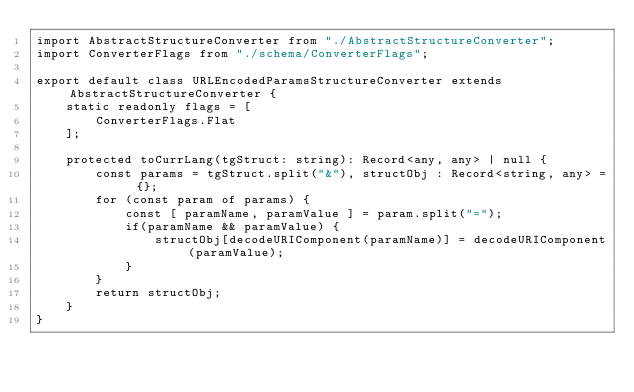<code> <loc_0><loc_0><loc_500><loc_500><_TypeScript_>import AbstractStructureConverter from "./AbstractStructureConverter";
import ConverterFlags from "./schema/ConverterFlags";

export default class URLEncodedParamsStructureConverter extends AbstractStructureConverter {
    static readonly flags = [
        ConverterFlags.Flat
    ];
    
    protected toCurrLang(tgStruct: string): Record<any, any> | null {
        const params = tgStruct.split("&"), structObj : Record<string, any> = {};
        for (const param of params) {
            const [ paramName, paramValue ] = param.split("=");
            if(paramName && paramValue) {
                structObj[decodeURIComponent(paramName)] = decodeURIComponent(paramValue);
            }
        }
        return structObj;
    }
}</code> 